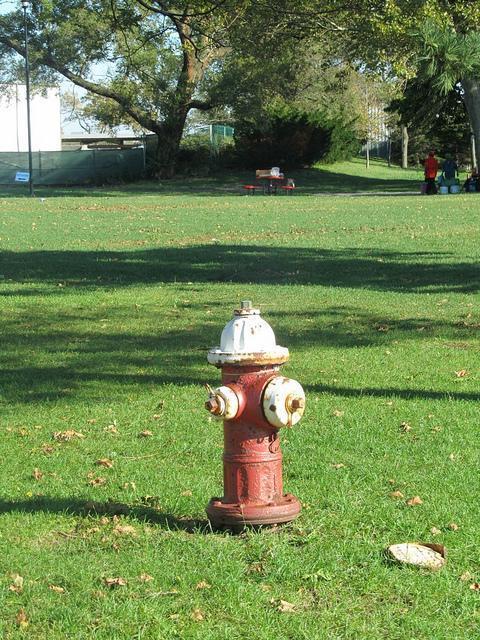How many giraffes are here?
Give a very brief answer. 0. 